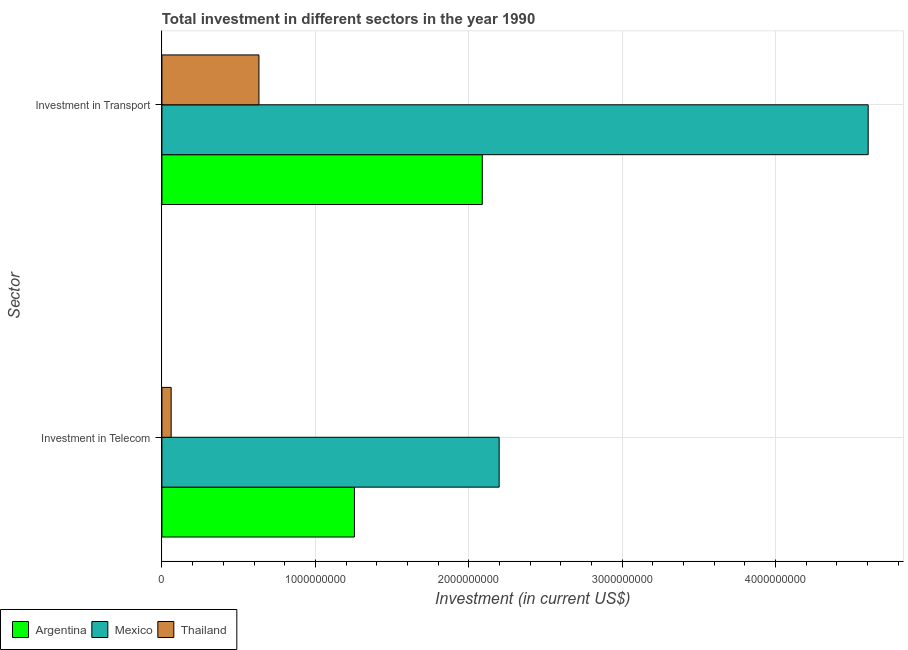Are the number of bars per tick equal to the number of legend labels?
Give a very brief answer. Yes. Are the number of bars on each tick of the Y-axis equal?
Give a very brief answer. Yes. How many bars are there on the 1st tick from the bottom?
Make the answer very short. 3. What is the label of the 1st group of bars from the top?
Keep it short and to the point. Investment in Transport. What is the investment in transport in Thailand?
Offer a terse response. 6.32e+08. Across all countries, what is the maximum investment in telecom?
Offer a terse response. 2.20e+09. Across all countries, what is the minimum investment in transport?
Keep it short and to the point. 6.32e+08. In which country was the investment in telecom maximum?
Your response must be concise. Mexico. In which country was the investment in telecom minimum?
Keep it short and to the point. Thailand. What is the total investment in telecom in the graph?
Offer a terse response. 3.51e+09. What is the difference between the investment in transport in Mexico and that in Thailand?
Your response must be concise. 3.97e+09. What is the difference between the investment in transport in Argentina and the investment in telecom in Mexico?
Give a very brief answer. -1.10e+08. What is the average investment in telecom per country?
Your answer should be compact. 1.17e+09. What is the difference between the investment in telecom and investment in transport in Thailand?
Your answer should be very brief. -5.72e+08. In how many countries, is the investment in telecom greater than 4200000000 US$?
Ensure brevity in your answer.  0. What is the ratio of the investment in telecom in Mexico to that in Thailand?
Provide a succinct answer. 36.63. What does the 1st bar from the top in Investment in Transport represents?
Your answer should be very brief. Thailand. How many bars are there?
Offer a very short reply. 6. Are all the bars in the graph horizontal?
Your answer should be compact. Yes. How many countries are there in the graph?
Offer a terse response. 3. Does the graph contain any zero values?
Provide a succinct answer. No. Where does the legend appear in the graph?
Keep it short and to the point. Bottom left. How many legend labels are there?
Give a very brief answer. 3. What is the title of the graph?
Ensure brevity in your answer.  Total investment in different sectors in the year 1990. What is the label or title of the X-axis?
Your answer should be very brief. Investment (in current US$). What is the label or title of the Y-axis?
Offer a very short reply. Sector. What is the Investment (in current US$) of Argentina in Investment in Telecom?
Make the answer very short. 1.25e+09. What is the Investment (in current US$) in Mexico in Investment in Telecom?
Ensure brevity in your answer.  2.20e+09. What is the Investment (in current US$) of Thailand in Investment in Telecom?
Your answer should be very brief. 6.00e+07. What is the Investment (in current US$) of Argentina in Investment in Transport?
Keep it short and to the point. 2.09e+09. What is the Investment (in current US$) in Mexico in Investment in Transport?
Your answer should be compact. 4.60e+09. What is the Investment (in current US$) in Thailand in Investment in Transport?
Make the answer very short. 6.32e+08. Across all Sector, what is the maximum Investment (in current US$) of Argentina?
Ensure brevity in your answer.  2.09e+09. Across all Sector, what is the maximum Investment (in current US$) of Mexico?
Your answer should be very brief. 4.60e+09. Across all Sector, what is the maximum Investment (in current US$) of Thailand?
Keep it short and to the point. 6.32e+08. Across all Sector, what is the minimum Investment (in current US$) of Argentina?
Ensure brevity in your answer.  1.25e+09. Across all Sector, what is the minimum Investment (in current US$) in Mexico?
Make the answer very short. 2.20e+09. Across all Sector, what is the minimum Investment (in current US$) of Thailand?
Make the answer very short. 6.00e+07. What is the total Investment (in current US$) in Argentina in the graph?
Provide a short and direct response. 3.34e+09. What is the total Investment (in current US$) of Mexico in the graph?
Offer a very short reply. 6.80e+09. What is the total Investment (in current US$) in Thailand in the graph?
Give a very brief answer. 6.92e+08. What is the difference between the Investment (in current US$) in Argentina in Investment in Telecom and that in Investment in Transport?
Give a very brief answer. -8.33e+08. What is the difference between the Investment (in current US$) of Mexico in Investment in Telecom and that in Investment in Transport?
Your response must be concise. -2.41e+09. What is the difference between the Investment (in current US$) in Thailand in Investment in Telecom and that in Investment in Transport?
Offer a very short reply. -5.72e+08. What is the difference between the Investment (in current US$) in Argentina in Investment in Telecom and the Investment (in current US$) in Mexico in Investment in Transport?
Offer a terse response. -3.35e+09. What is the difference between the Investment (in current US$) of Argentina in Investment in Telecom and the Investment (in current US$) of Thailand in Investment in Transport?
Your answer should be very brief. 6.22e+08. What is the difference between the Investment (in current US$) in Mexico in Investment in Telecom and the Investment (in current US$) in Thailand in Investment in Transport?
Provide a succinct answer. 1.57e+09. What is the average Investment (in current US$) in Argentina per Sector?
Ensure brevity in your answer.  1.67e+09. What is the average Investment (in current US$) of Mexico per Sector?
Your answer should be compact. 3.40e+09. What is the average Investment (in current US$) of Thailand per Sector?
Provide a succinct answer. 3.46e+08. What is the difference between the Investment (in current US$) in Argentina and Investment (in current US$) in Mexico in Investment in Telecom?
Make the answer very short. -9.43e+08. What is the difference between the Investment (in current US$) in Argentina and Investment (in current US$) in Thailand in Investment in Telecom?
Give a very brief answer. 1.19e+09. What is the difference between the Investment (in current US$) of Mexico and Investment (in current US$) of Thailand in Investment in Telecom?
Make the answer very short. 2.14e+09. What is the difference between the Investment (in current US$) of Argentina and Investment (in current US$) of Mexico in Investment in Transport?
Give a very brief answer. -2.52e+09. What is the difference between the Investment (in current US$) of Argentina and Investment (in current US$) of Thailand in Investment in Transport?
Provide a succinct answer. 1.46e+09. What is the difference between the Investment (in current US$) in Mexico and Investment (in current US$) in Thailand in Investment in Transport?
Make the answer very short. 3.97e+09. What is the ratio of the Investment (in current US$) of Argentina in Investment in Telecom to that in Investment in Transport?
Provide a short and direct response. 0.6. What is the ratio of the Investment (in current US$) of Mexico in Investment in Telecom to that in Investment in Transport?
Your response must be concise. 0.48. What is the ratio of the Investment (in current US$) in Thailand in Investment in Telecom to that in Investment in Transport?
Make the answer very short. 0.09. What is the difference between the highest and the second highest Investment (in current US$) of Argentina?
Ensure brevity in your answer.  8.33e+08. What is the difference between the highest and the second highest Investment (in current US$) in Mexico?
Keep it short and to the point. 2.41e+09. What is the difference between the highest and the second highest Investment (in current US$) in Thailand?
Make the answer very short. 5.72e+08. What is the difference between the highest and the lowest Investment (in current US$) in Argentina?
Your answer should be compact. 8.33e+08. What is the difference between the highest and the lowest Investment (in current US$) in Mexico?
Provide a short and direct response. 2.41e+09. What is the difference between the highest and the lowest Investment (in current US$) of Thailand?
Give a very brief answer. 5.72e+08. 